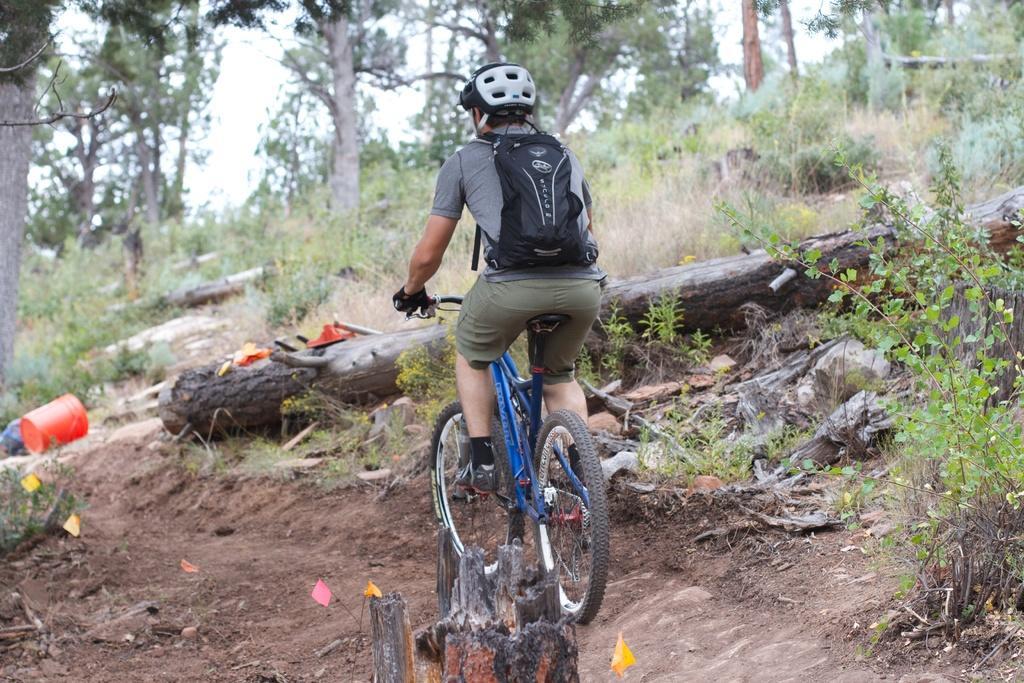Please provide a concise description of this image. There is a person riding a bicycle. Here we can see plants, grass, and trees. In the background there is sky. 